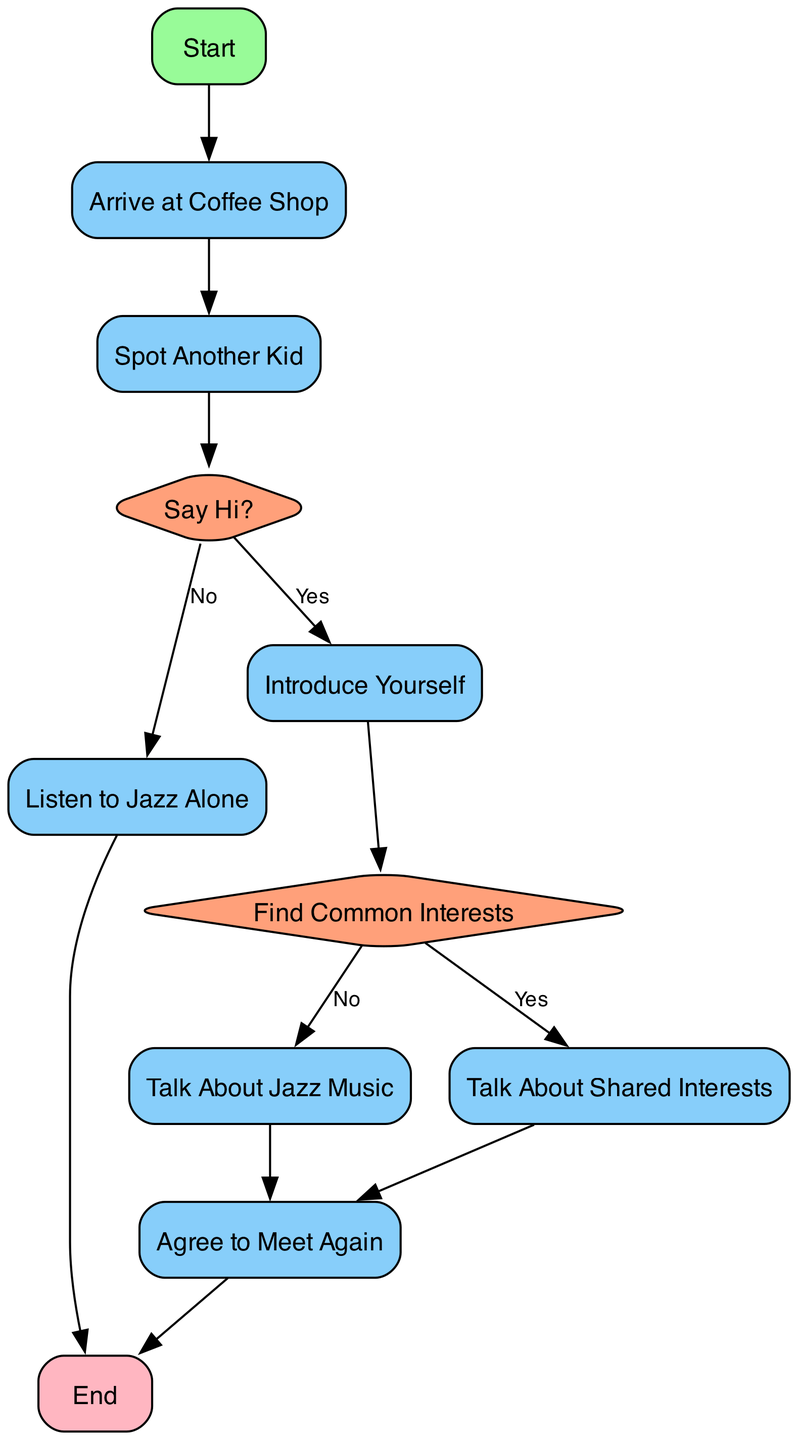What is the first action in the flow chart? The first action in the flow chart is labeled "Start". This indicates where the process begins when trying to make a new friend at the coffee shop.
Answer: Start What is the decision point in the diagram? The decision point in the diagram is labeled "Say Hi?". This is where the process divides based on whether or not the child decides to say hello to another kid.
Answer: Say Hi? How many process nodes are there in the diagram? The diagram contains five process nodes: "Arrive at Coffee Shop", "Listen to Jazz Alone", "Introduce Yourself", "Talk About Jazz Music", and "Agree to Meet Again". Counting these gives a total of five process nodes.
Answer: Five What happens if the answer to "Say Hi?" is No? If the answer to "Say Hi?" is No, the flow moves to the process labeled "Listen to Jazz Alone", which leads directly to the end of the flow chart. This shows that not saying hi results in solitude while enjoying the music.
Answer: Listen to Jazz Alone What do you find at the end of the flow chart? At the end of the flow chart, it states "End". This marks the conclusion of the process, indicating that the steps towards making a friend have come to a close, either successfully or through solitude.
Answer: End What action follows after saying hi? After saying hi, the next action is to "Introduce Yourself". This implies that making a friend involves putting oneself forward immediately after initiating contact.
Answer: Introduce Yourself What is the final outcome if common interests are found? If common interests are found, the flow progresses to "Talk About Shared Interests", which leads to "Agree to Meet Again". Thus, finding common interests moves the relationship closer to friendship.
Answer: Agree to Meet Again If the child talks about jazz music, what happens next? If the child talks about jazz music, the next step is to "Agree to Meet Again". This shows that even discussing just one interest can still lead to forming plans for future encounters.
Answer: Agree to Meet Again What color represents decision nodes in the diagram? The decision nodes in the diagram are colored light salmon. This color distinction helps to differentiate decision points from other types of nodes, like processes and start/end.
Answer: Light salmon 